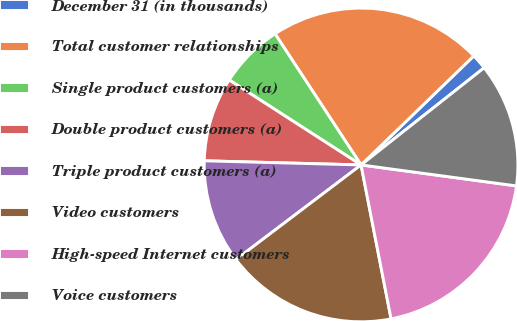Convert chart. <chart><loc_0><loc_0><loc_500><loc_500><pie_chart><fcel>December 31 (in thousands)<fcel>Total customer relationships<fcel>Single product customers (a)<fcel>Double product customers (a)<fcel>Triple product customers (a)<fcel>Video customers<fcel>High-speed Internet customers<fcel>Voice customers<nl><fcel>1.6%<fcel>22.01%<fcel>6.65%<fcel>8.69%<fcel>10.73%<fcel>17.76%<fcel>19.8%<fcel>12.77%<nl></chart> 